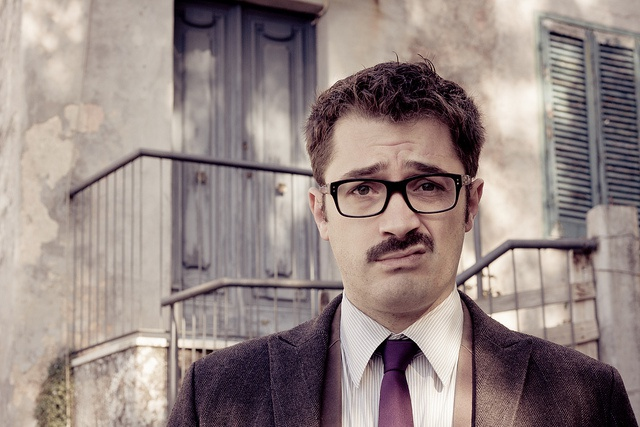Describe the objects in this image and their specific colors. I can see people in lightgray, black, brown, tan, and gray tones and tie in lightgray, black, and purple tones in this image. 